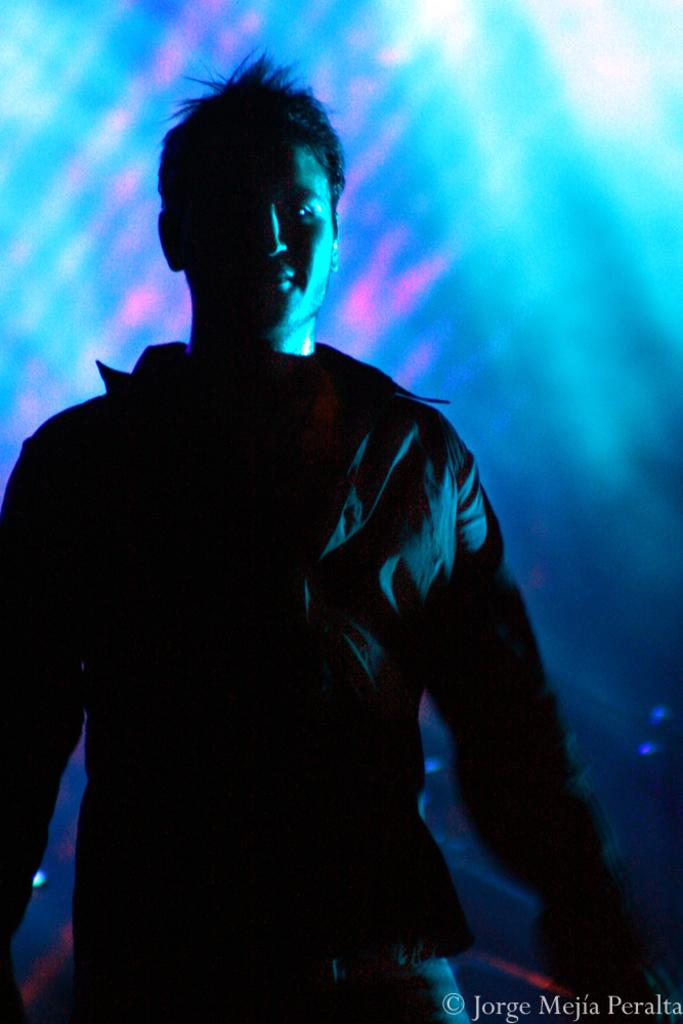What is the main subject of the image? There is a person standing in the center of the image. What is the person wearing? The person is wearing a jacket. Is there any text present in the image? Yes, there is some text at the bottom of the image. How many leaves can be seen on the person's neck in the image? There are no leaves present in the image, and therefore none can be seen on the person's neck. What type of camp is visible in the background of the image? There is no camp visible in the image; it only features a person standing in the center and some text at the bottom. 